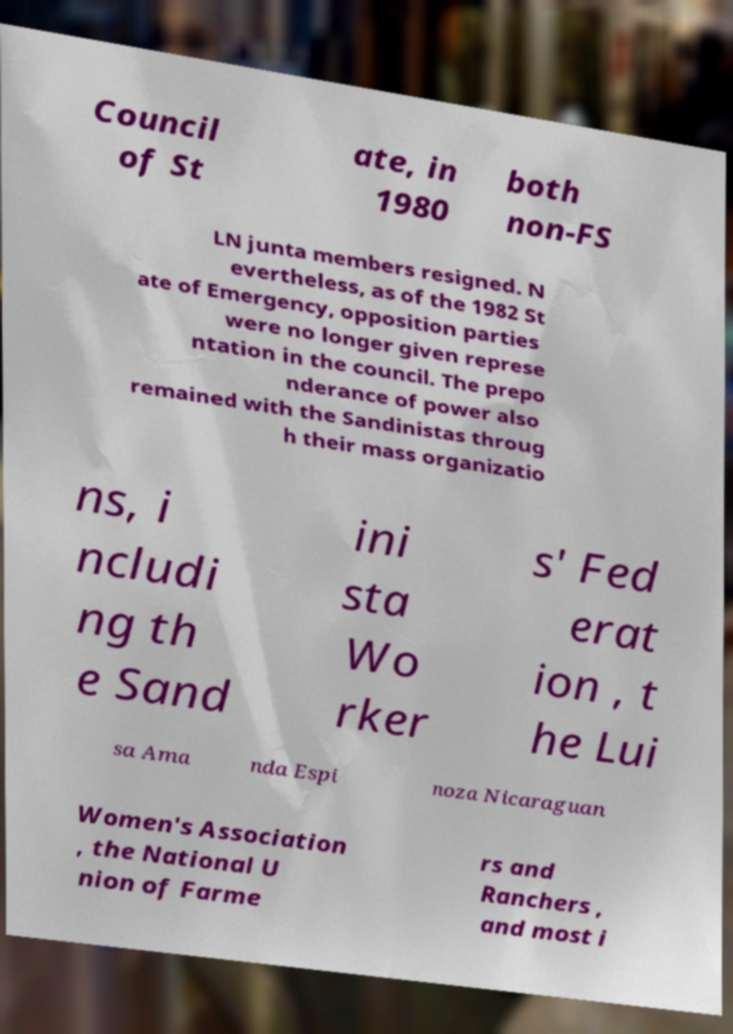I need the written content from this picture converted into text. Can you do that? Council of St ate, in 1980 both non-FS LN junta members resigned. N evertheless, as of the 1982 St ate of Emergency, opposition parties were no longer given represe ntation in the council. The prepo nderance of power also remained with the Sandinistas throug h their mass organizatio ns, i ncludi ng th e Sand ini sta Wo rker s' Fed erat ion , t he Lui sa Ama nda Espi noza Nicaraguan Women's Association , the National U nion of Farme rs and Ranchers , and most i 